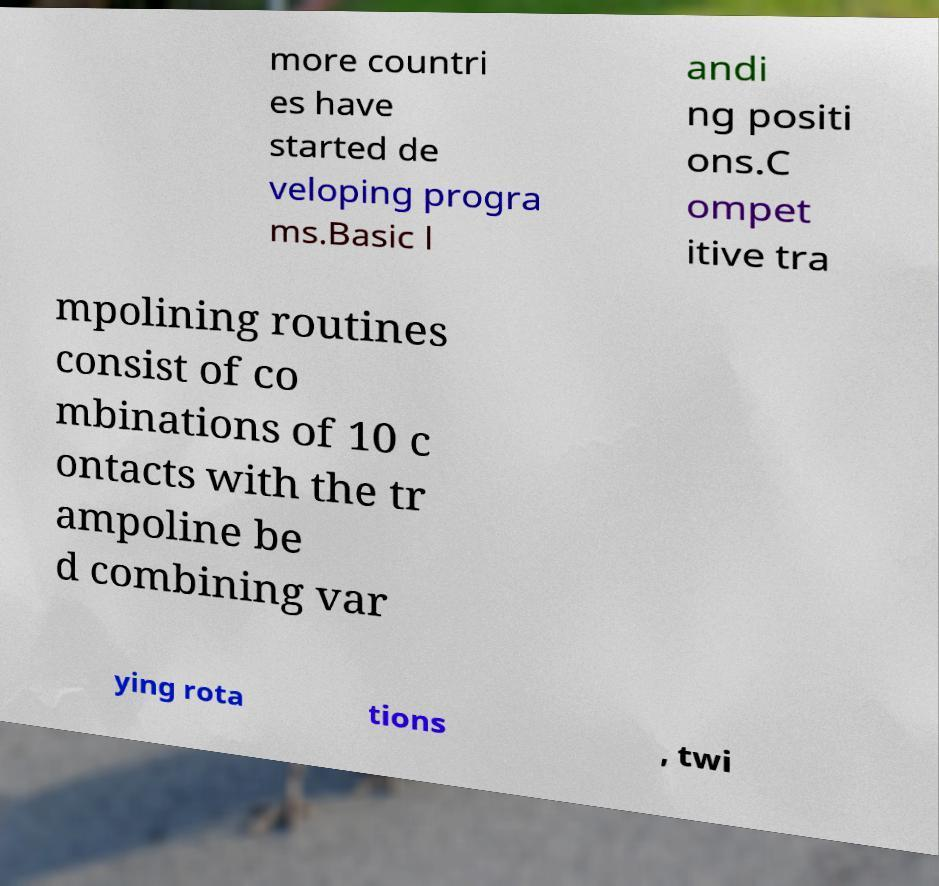Please identify and transcribe the text found in this image. more countri es have started de veloping progra ms.Basic l andi ng positi ons.C ompet itive tra mpolining routines consist of co mbinations of 10 c ontacts with the tr ampoline be d combining var ying rota tions , twi 